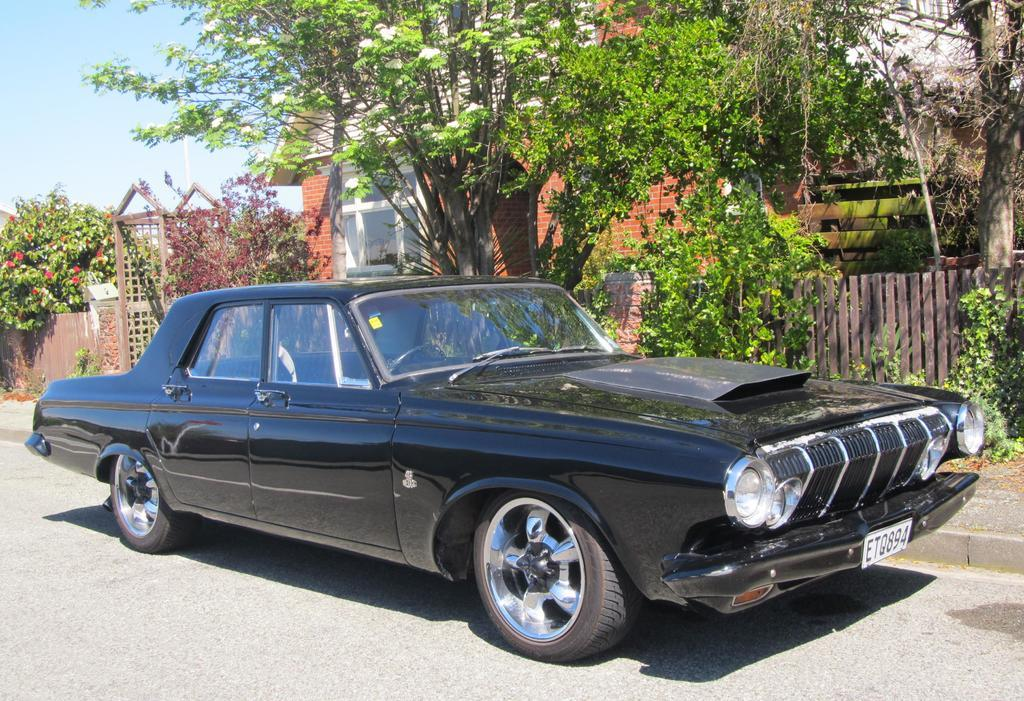What type of vegetation can be seen in the image? There are trees in the image. What type of structure is present in the image? There is a house in the image. What feature of the house is mentioned in the facts? The house has windows. What type of flowers can be seen in the image? There are red color flowers in the image. What type of barrier is present in the image? There is fencing in the image. What type of vehicle is present in the image? There is a black color car on the road. What is the color of the sky in the image? The sky is blue and white in color. What type of bedroom can be seen in the image? There is no bedroom present in the image. What is the taste of the red color flowers in the image? Flowers do not have a taste, and the image does not provide any information about the taste of the flowers. 